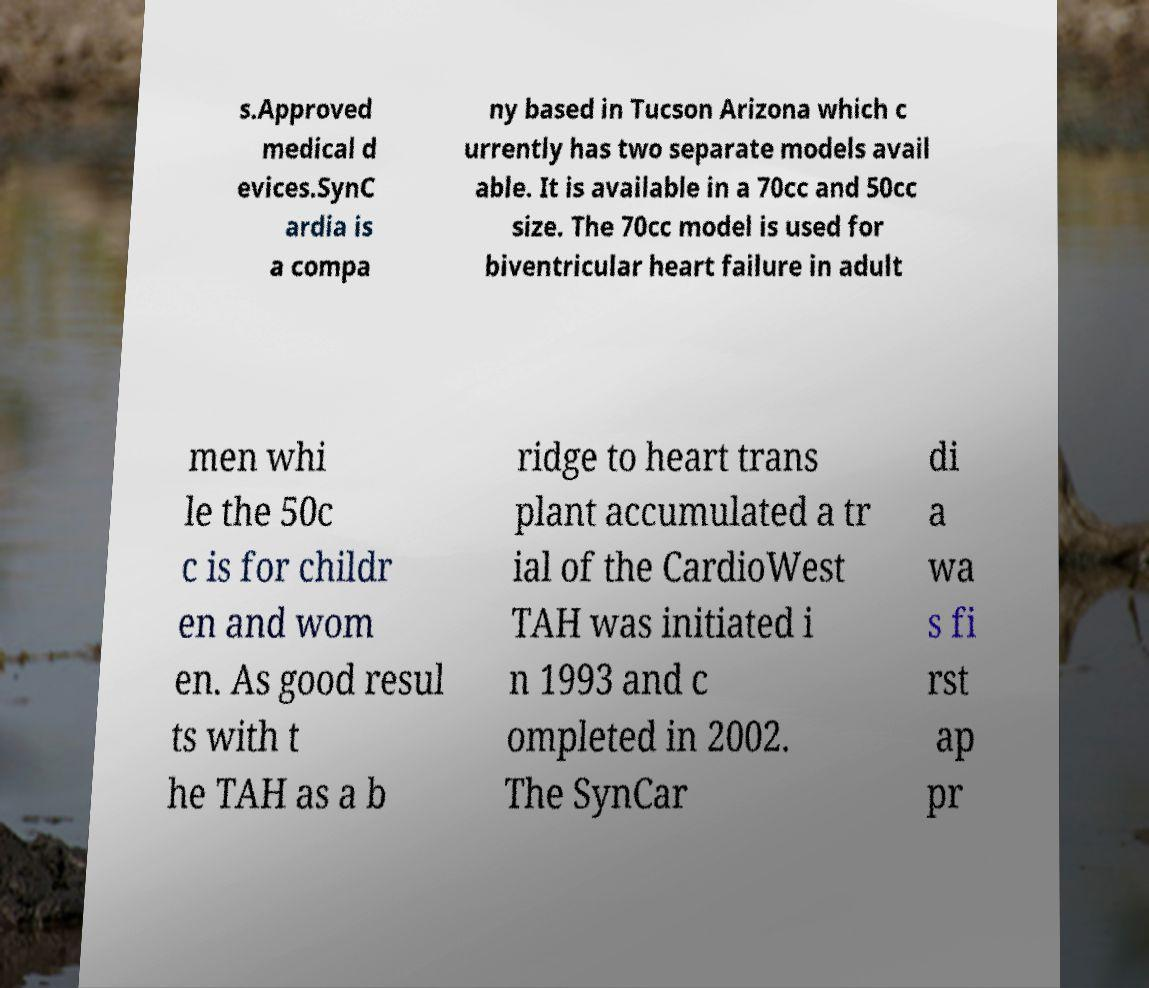I need the written content from this picture converted into text. Can you do that? s.Approved medical d evices.SynC ardia is a compa ny based in Tucson Arizona which c urrently has two separate models avail able. It is available in a 70cc and 50cc size. The 70cc model is used for biventricular heart failure in adult men whi le the 50c c is for childr en and wom en. As good resul ts with t he TAH as a b ridge to heart trans plant accumulated a tr ial of the CardioWest TAH was initiated i n 1993 and c ompleted in 2002. The SynCar di a wa s fi rst ap pr 